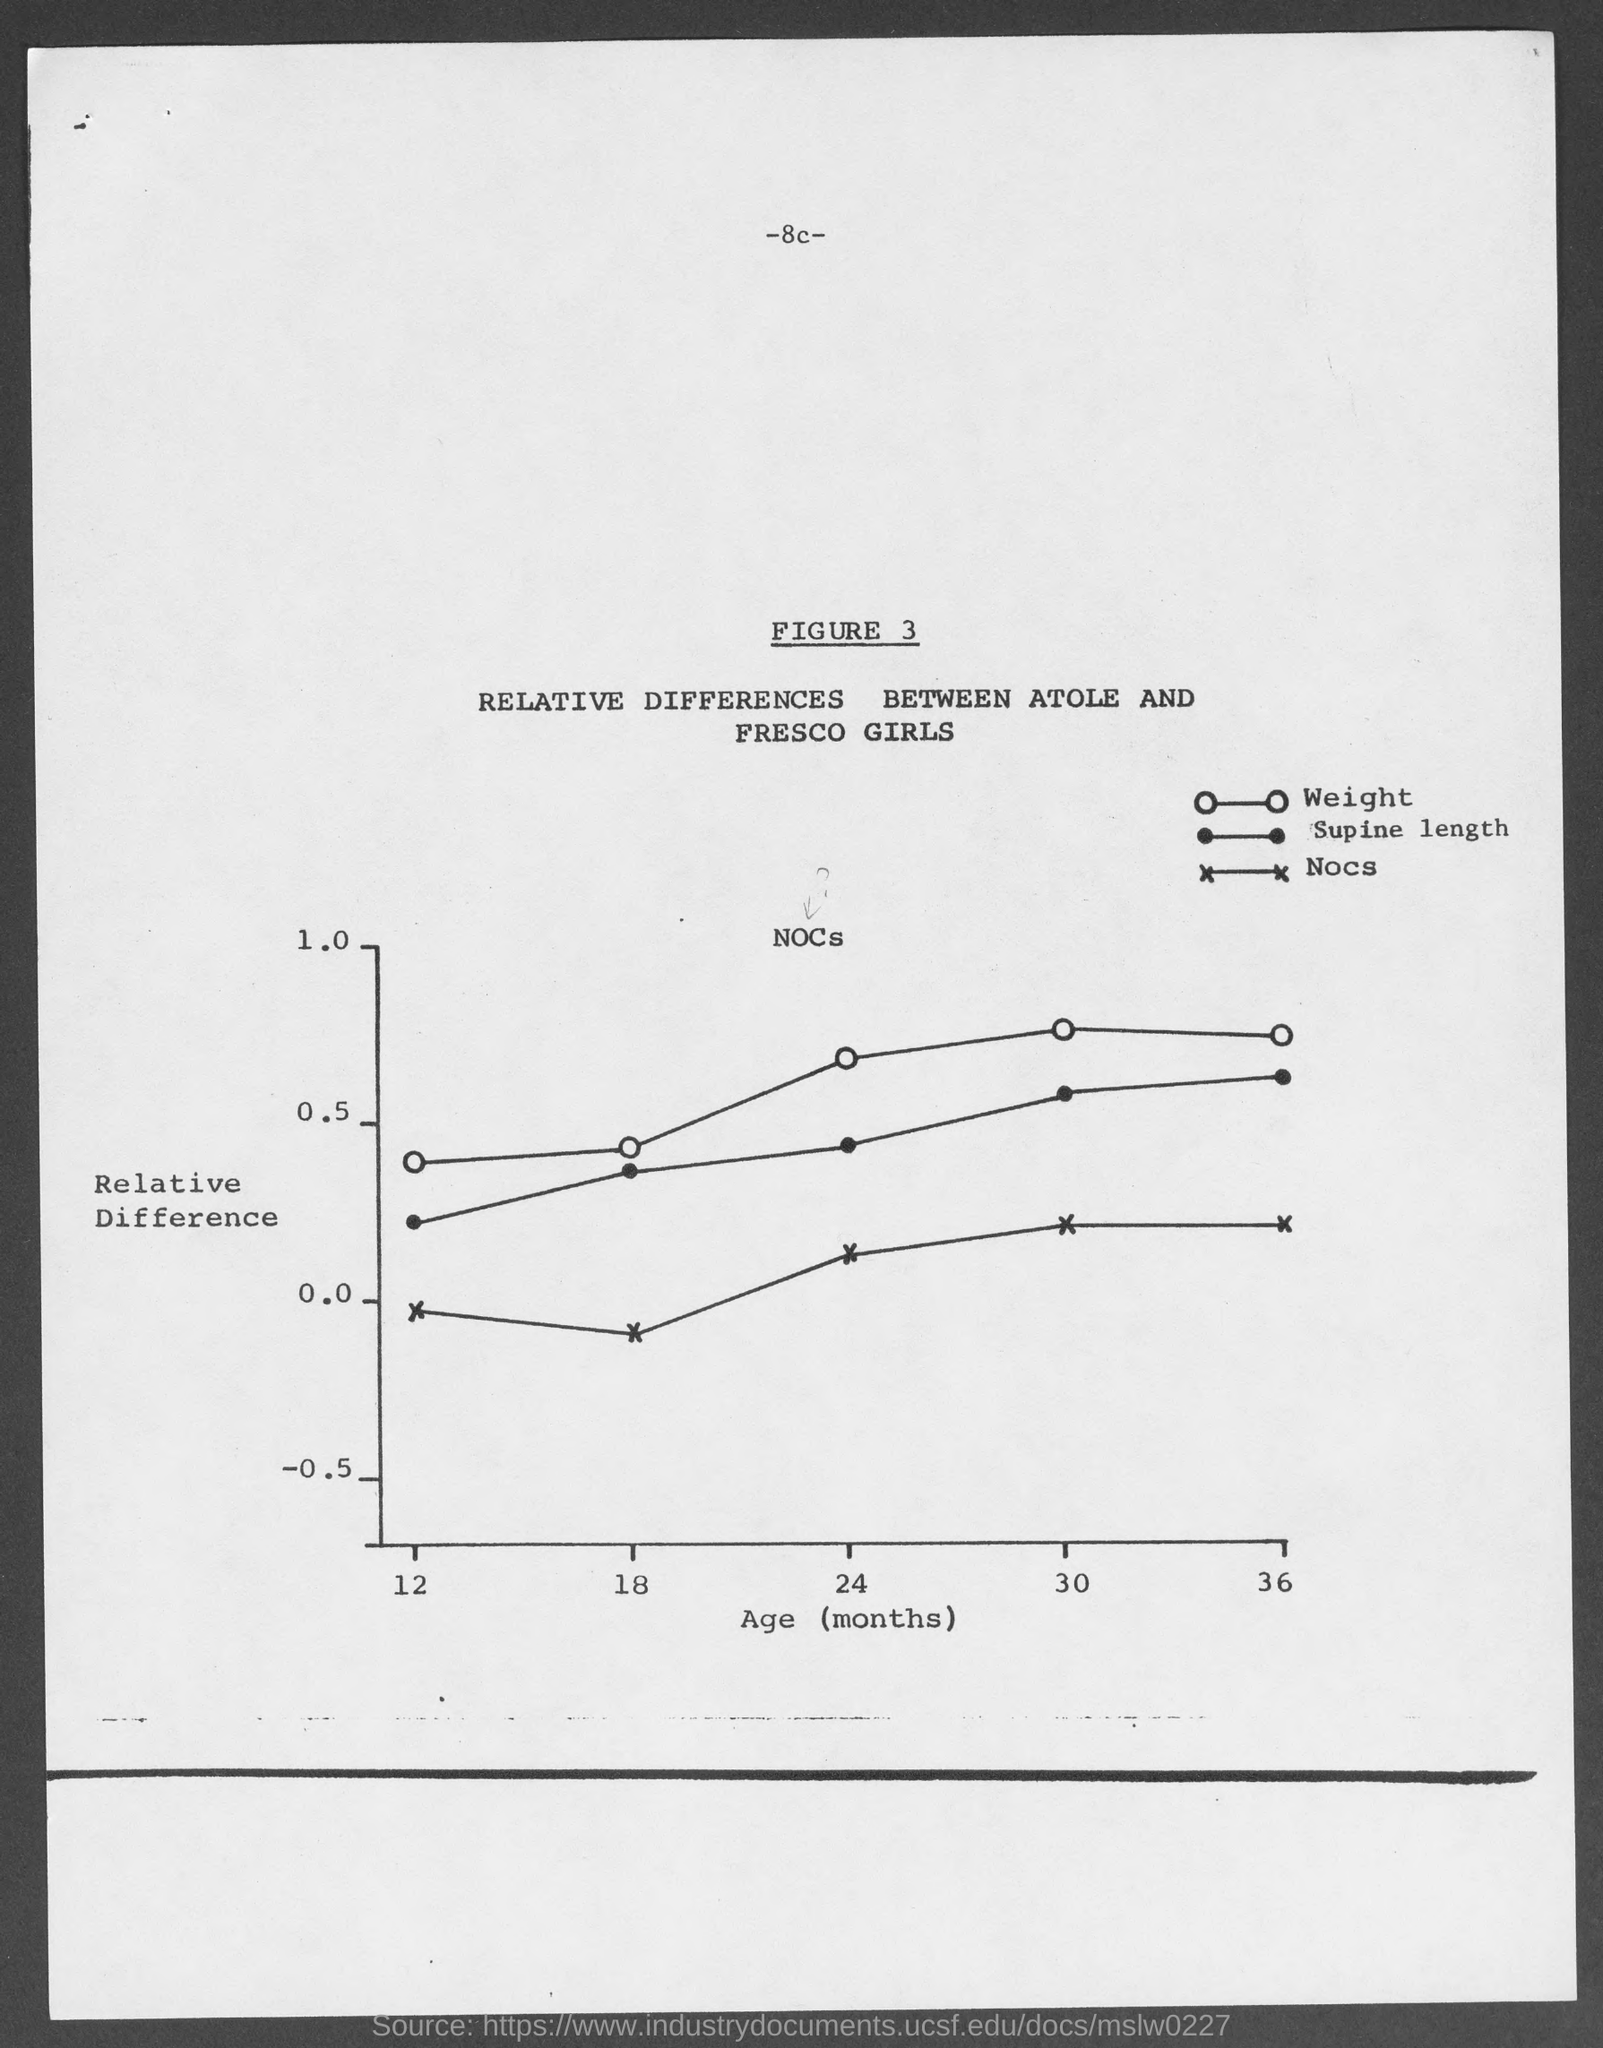What do the different symbols on the chart represent? In this graph, each symbol represents a specific measurement for comparing the two groups of girls. The open circles indicate weight, the closed circles show supine length, and the crosses represent nocs, which might be a specific measurement or data point relevant to the study. 